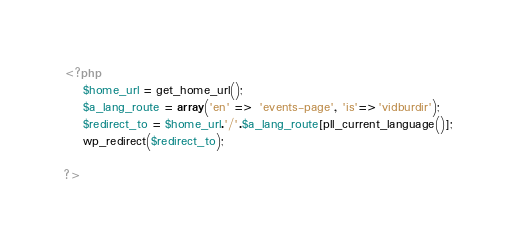Convert code to text. <code><loc_0><loc_0><loc_500><loc_500><_PHP_><?php
	$home_url = get_home_url();
	$a_lang_route = array('en' => 'events-page', 'is'=>'vidburdir');
	$redirect_to = $home_url.'/'.$a_lang_route[pll_current_language()];
	wp_redirect($redirect_to);

?>


</code> 